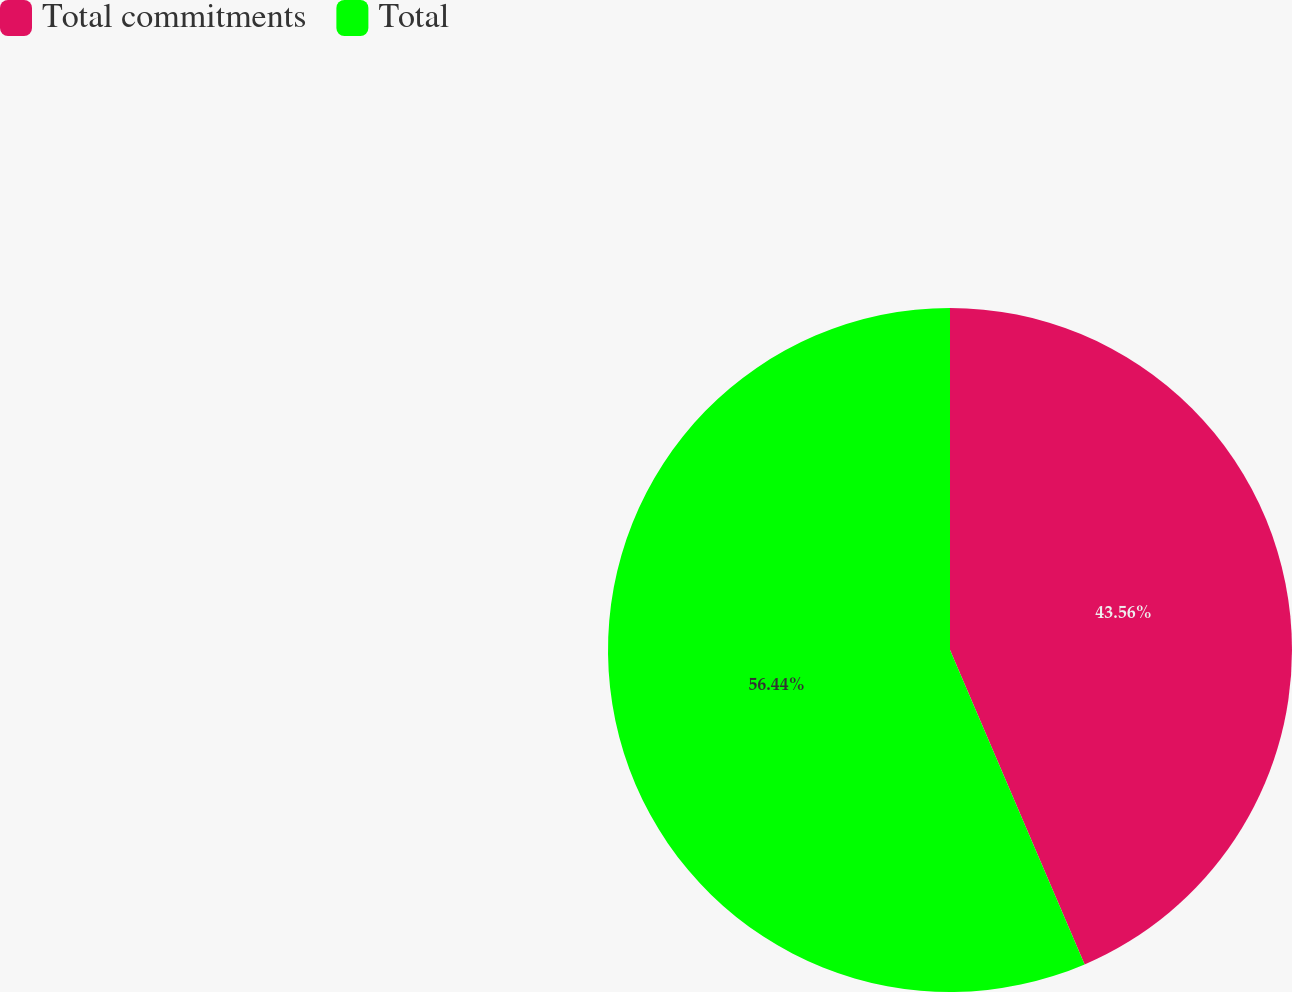<chart> <loc_0><loc_0><loc_500><loc_500><pie_chart><fcel>Total commitments<fcel>Total<nl><fcel>43.56%<fcel>56.44%<nl></chart> 